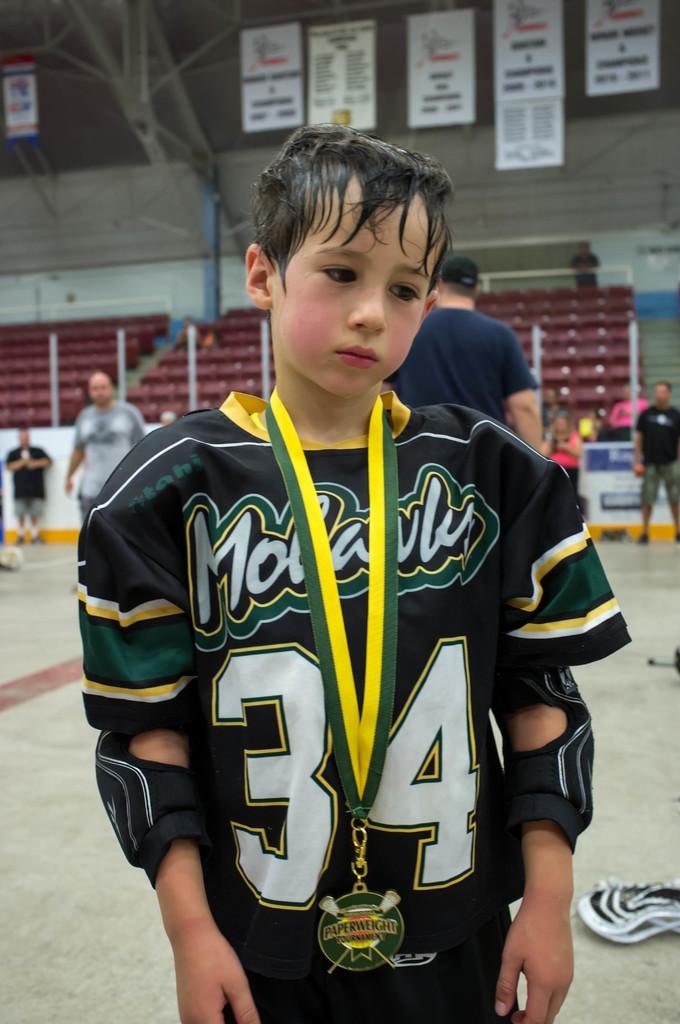Provide a one-sentence caption for the provided image. The kid here is wearing the number 34 on his jersey. 